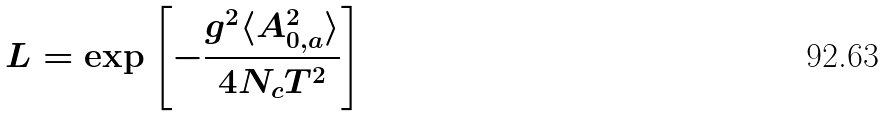Convert formula to latex. <formula><loc_0><loc_0><loc_500><loc_500>L = \exp \left [ - \frac { g ^ { 2 } \langle A _ { 0 , a } ^ { 2 } \rangle } { 4 N _ { c } T ^ { 2 } } \right ]</formula> 